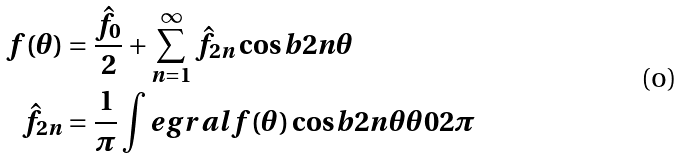Convert formula to latex. <formula><loc_0><loc_0><loc_500><loc_500>f ( \theta ) & = \frac { \hat { f } _ { 0 } } { 2 } + \sum _ { n = 1 } ^ { \infty } \hat { f } _ { 2 n } \cos b { 2 n \theta } \\ \hat { f } _ { 2 n } & = \frac { 1 } { \pi } \int e g r a l { f ( \theta ) \cos b { 2 n \theta } } { \theta } { 0 } { 2 \pi }</formula> 